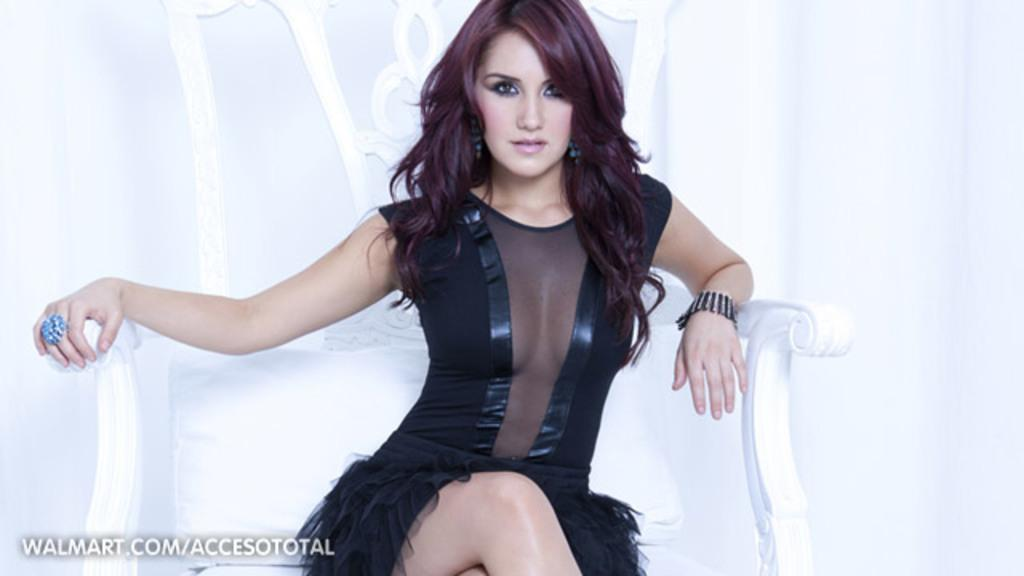Who is the main subject in the image? There is a girl in the image. What is the girl wearing in the image? The girl is wearing a black dress. What is the girl sitting on in the image? The girl is sitting on a white chair. What accessories is the girl wearing in the image? The girl is wearing a bracelet and a ring. How many apples are being smashed by the girl in the image? There are no apples or smashing actions present in the image. 